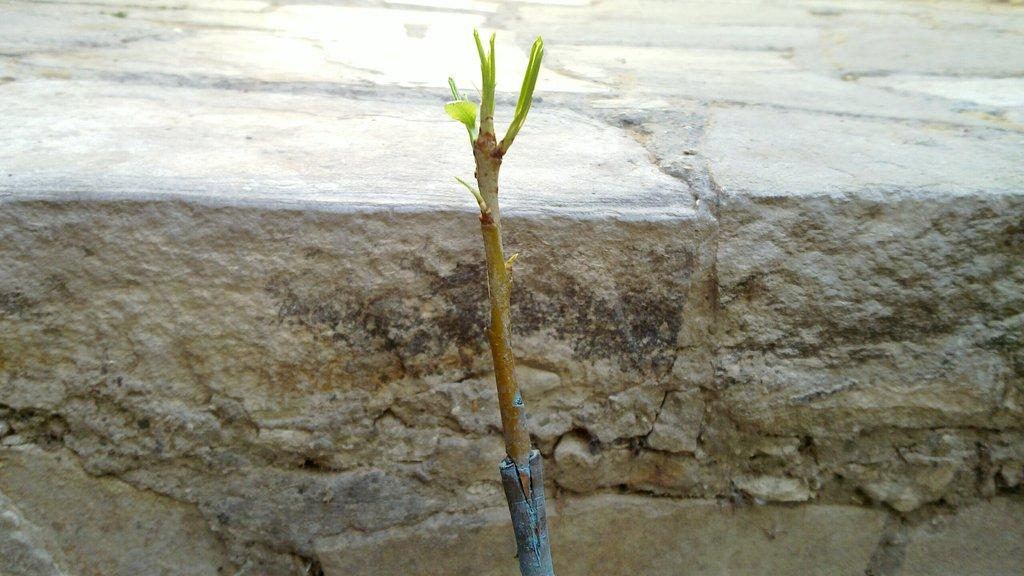What type of living organism can be seen in the image? There is a plant in the image. What is the primary background element in the image? There is a wall in the image. Is there any rain visible in the image? There is no rain visible in the image. What type of test can be seen being conducted on the plant in the image? There is no test being conducted on the plant in the image. 